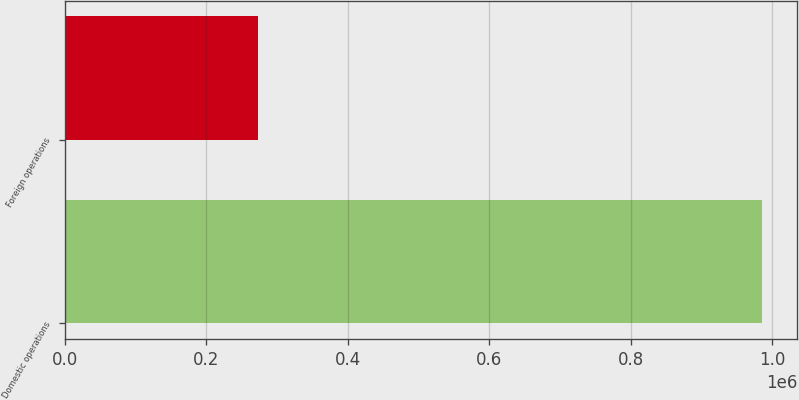Convert chart. <chart><loc_0><loc_0><loc_500><loc_500><bar_chart><fcel>Domestic operations<fcel>Foreign operations<nl><fcel>985683<fcel>273494<nl></chart> 